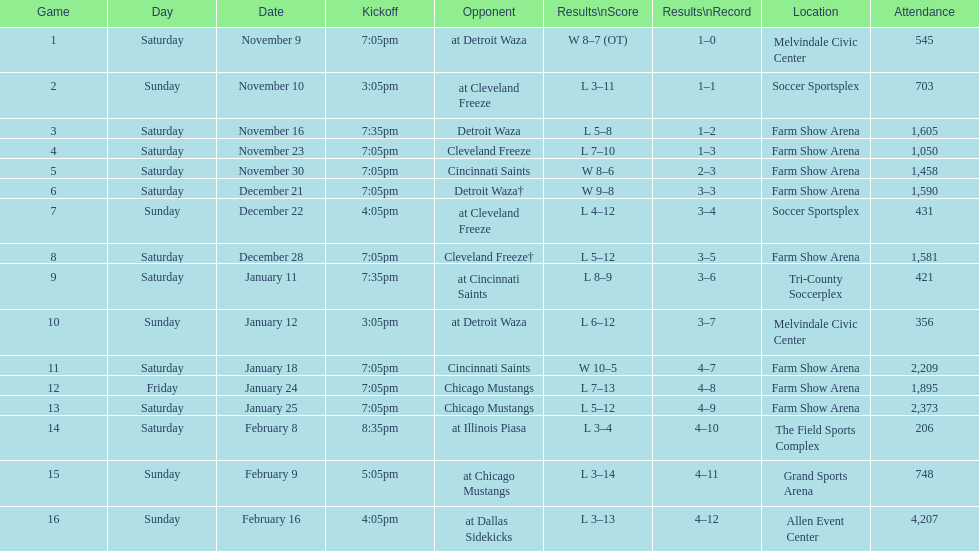Which opponent is listed after cleveland freeze in the table? Detroit Waza. Could you parse the entire table? {'header': ['Game', 'Day', 'Date', 'Kickoff', 'Opponent', 'Results\\nScore', 'Results\\nRecord', 'Location', 'Attendance'], 'rows': [['1', 'Saturday', 'November 9', '7:05pm', 'at Detroit Waza', 'W 8–7 (OT)', '1–0', 'Melvindale Civic Center', '545'], ['2', 'Sunday', 'November 10', '3:05pm', 'at Cleveland Freeze', 'L 3–11', '1–1', 'Soccer Sportsplex', '703'], ['3', 'Saturday', 'November 16', '7:35pm', 'Detroit Waza', 'L 5–8', '1–2', 'Farm Show Arena', '1,605'], ['4', 'Saturday', 'November 23', '7:05pm', 'Cleveland Freeze', 'L 7–10', '1–3', 'Farm Show Arena', '1,050'], ['5', 'Saturday', 'November 30', '7:05pm', 'Cincinnati Saints', 'W 8–6', '2–3', 'Farm Show Arena', '1,458'], ['6', 'Saturday', 'December 21', '7:05pm', 'Detroit Waza†', 'W 9–8', '3–3', 'Farm Show Arena', '1,590'], ['7', 'Sunday', 'December 22', '4:05pm', 'at Cleveland Freeze', 'L 4–12', '3–4', 'Soccer Sportsplex', '431'], ['8', 'Saturday', 'December 28', '7:05pm', 'Cleveland Freeze†', 'L 5–12', '3–5', 'Farm Show Arena', '1,581'], ['9', 'Saturday', 'January 11', '7:35pm', 'at Cincinnati Saints', 'L 8–9', '3–6', 'Tri-County Soccerplex', '421'], ['10', 'Sunday', 'January 12', '3:05pm', 'at Detroit Waza', 'L 6–12', '3–7', 'Melvindale Civic Center', '356'], ['11', 'Saturday', 'January 18', '7:05pm', 'Cincinnati Saints', 'W 10–5', '4–7', 'Farm Show Arena', '2,209'], ['12', 'Friday', 'January 24', '7:05pm', 'Chicago Mustangs', 'L 7–13', '4–8', 'Farm Show Arena', '1,895'], ['13', 'Saturday', 'January 25', '7:05pm', 'Chicago Mustangs', 'L 5–12', '4–9', 'Farm Show Arena', '2,373'], ['14', 'Saturday', 'February 8', '8:35pm', 'at Illinois Piasa', 'L 3–4', '4–10', 'The Field Sports Complex', '206'], ['15', 'Sunday', 'February 9', '5:05pm', 'at Chicago Mustangs', 'L 3–14', '4–11', 'Grand Sports Arena', '748'], ['16', 'Sunday', 'February 16', '4:05pm', 'at Dallas Sidekicks', 'L 3–13', '4–12', 'Allen Event Center', '4,207']]} 